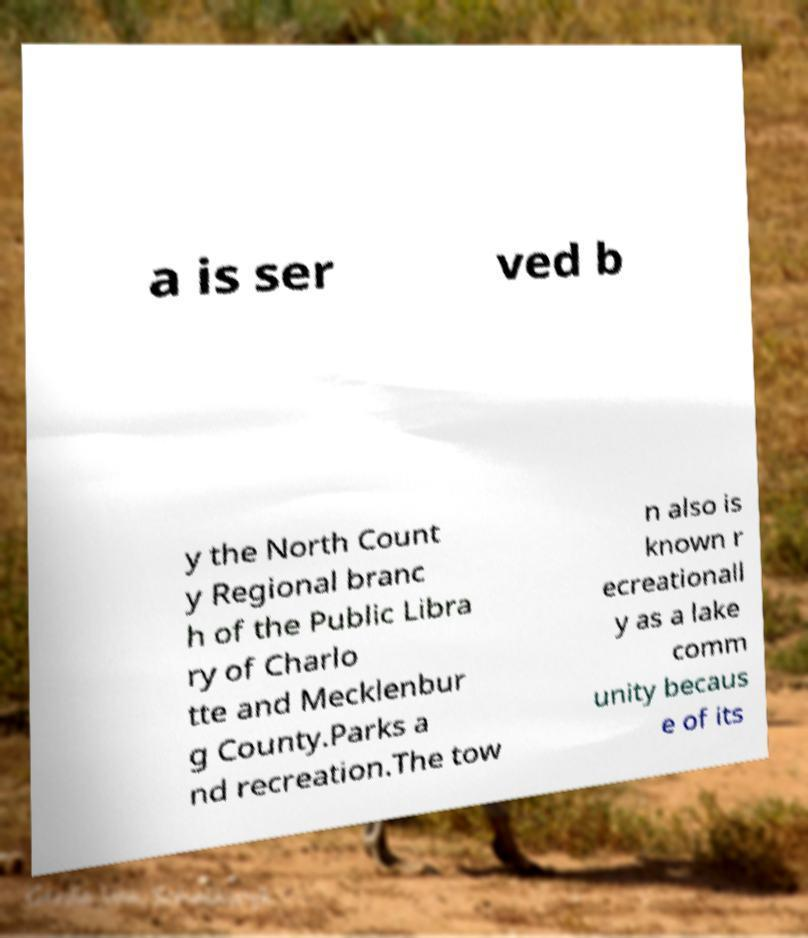Please identify and transcribe the text found in this image. a is ser ved b y the North Count y Regional branc h of the Public Libra ry of Charlo tte and Mecklenbur g County.Parks a nd recreation.The tow n also is known r ecreationall y as a lake comm unity becaus e of its 